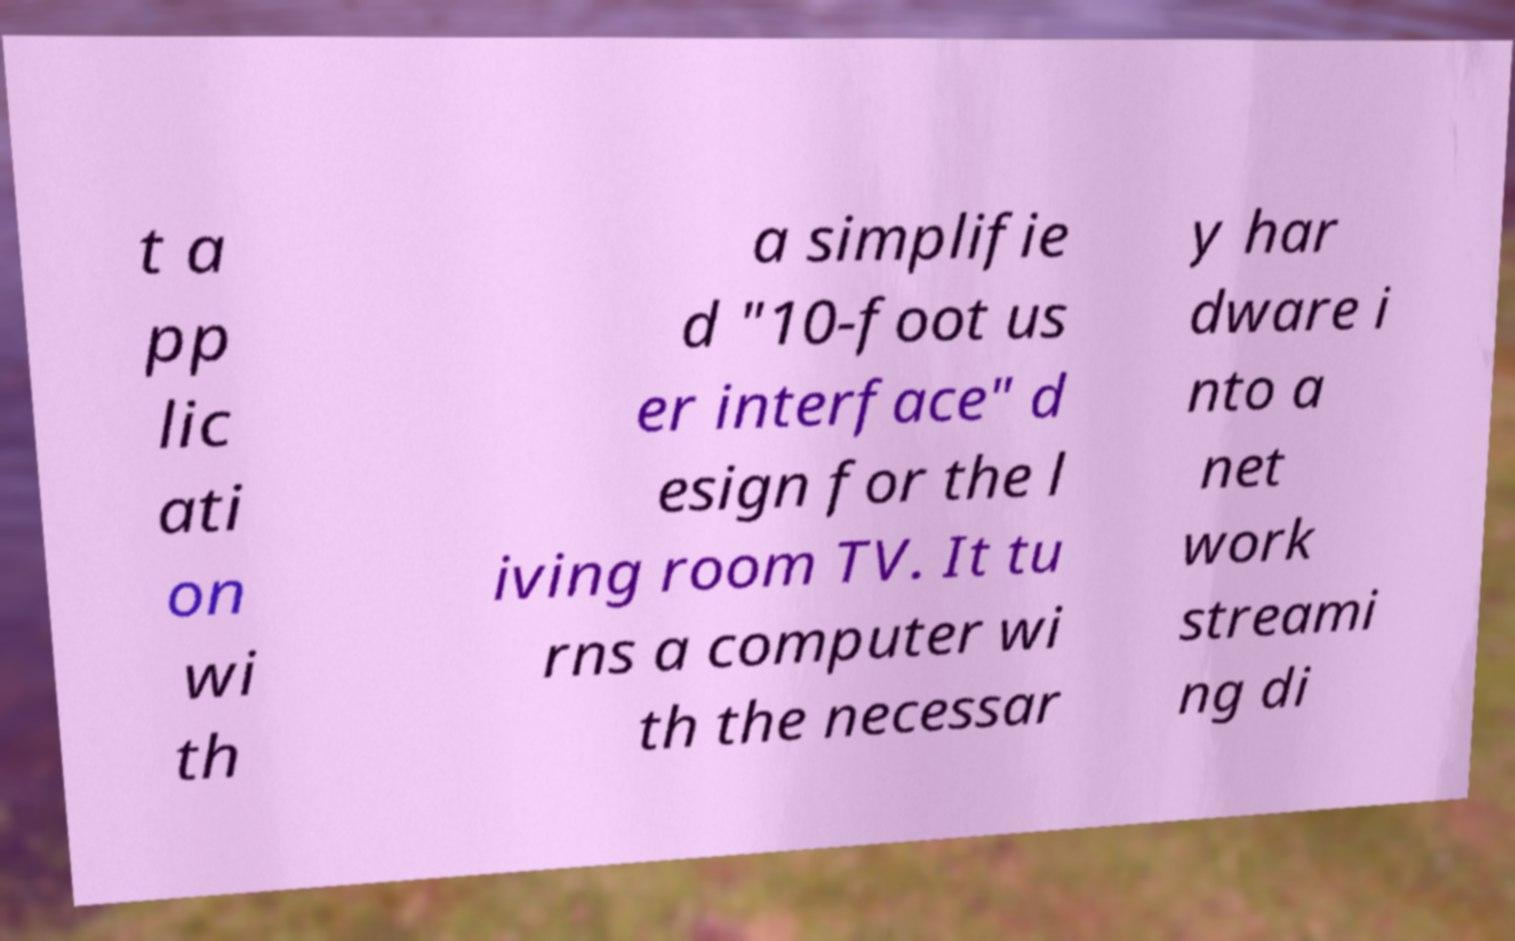Please identify and transcribe the text found in this image. t a pp lic ati on wi th a simplifie d "10-foot us er interface" d esign for the l iving room TV. It tu rns a computer wi th the necessar y har dware i nto a net work streami ng di 